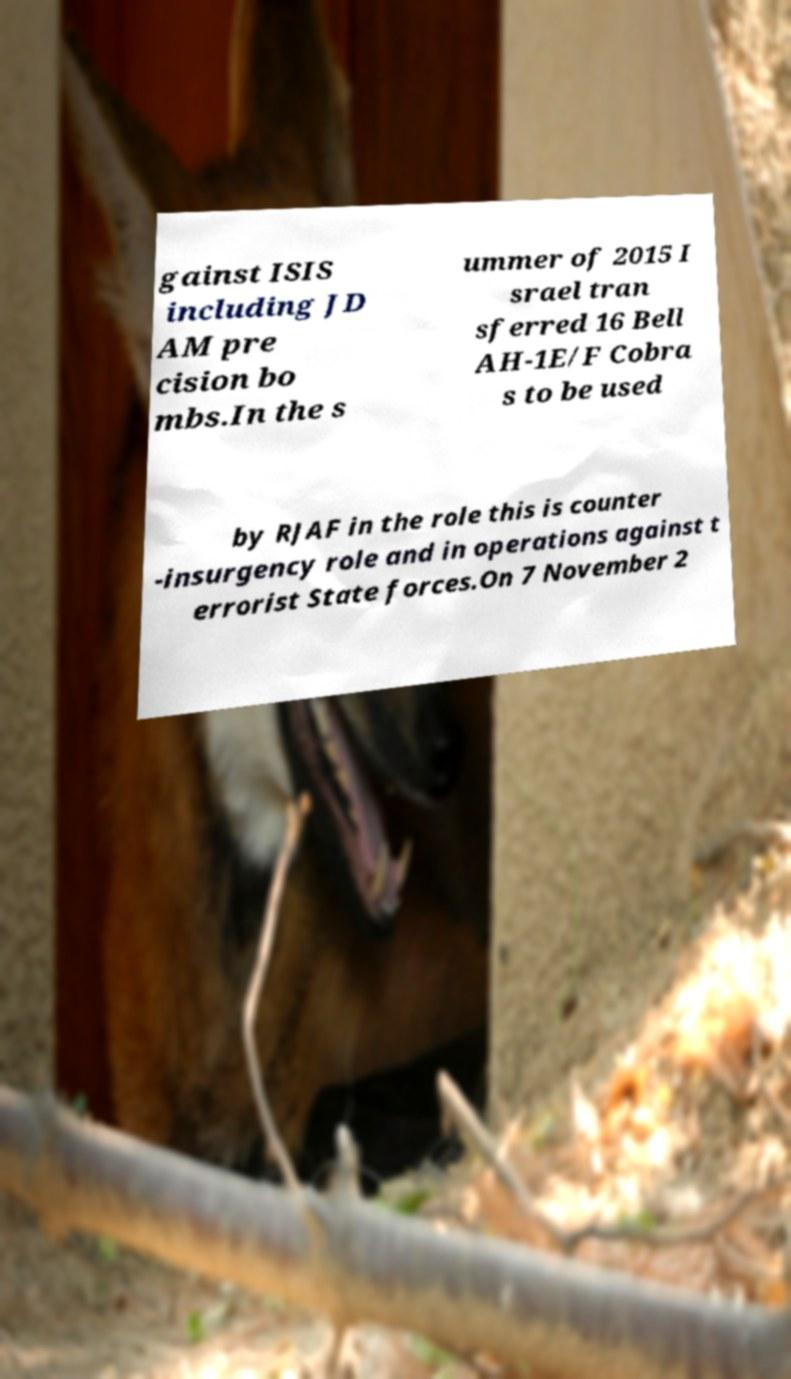Can you accurately transcribe the text from the provided image for me? gainst ISIS including JD AM pre cision bo mbs.In the s ummer of 2015 I srael tran sferred 16 Bell AH-1E/F Cobra s to be used by RJAF in the role this is counter -insurgency role and in operations against t errorist State forces.On 7 November 2 